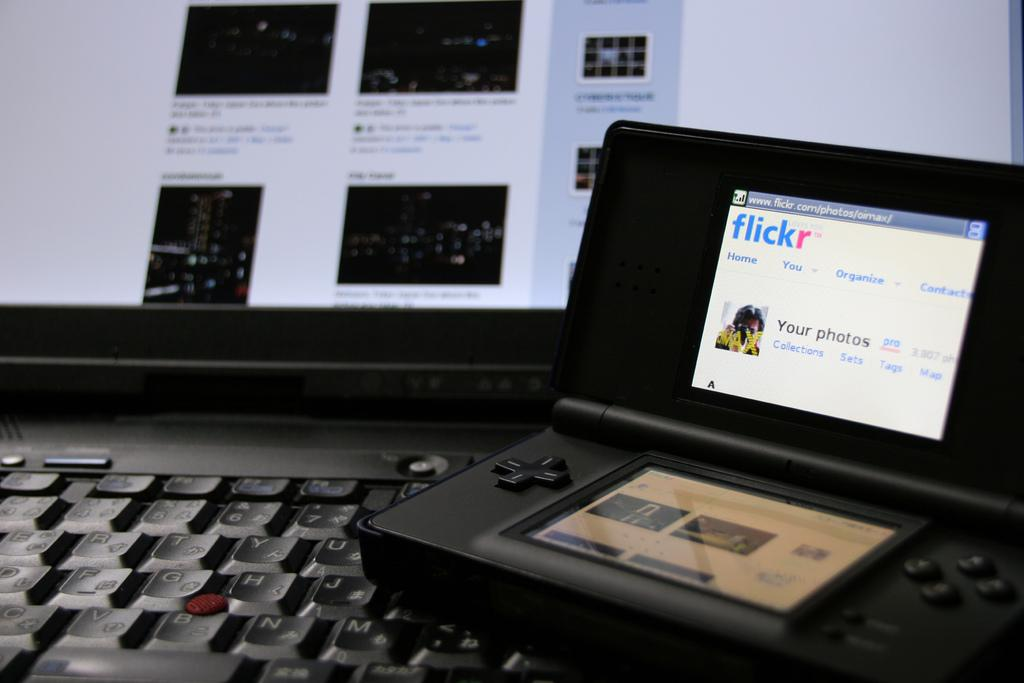What is the person holding in the image? The person is holding a guitar. What is the person doing with the guitar? The person is playing it. What type of gun can be seen in the image? There is no gun present in the image; it features a person holding and playing a guitar. 